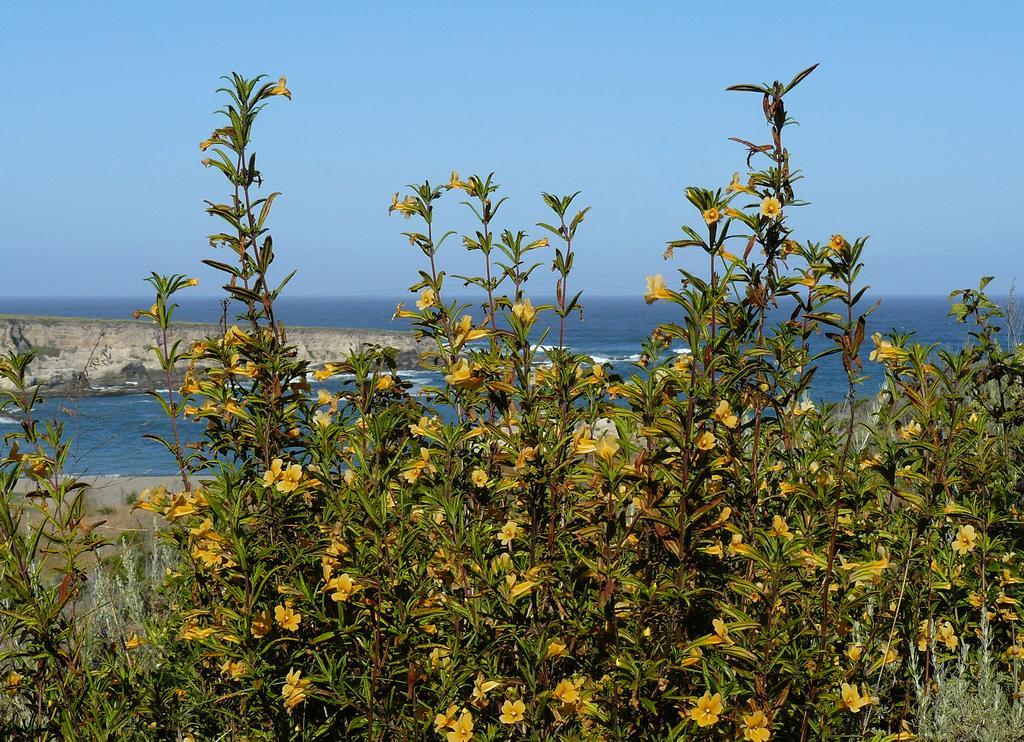Can you describe this image briefly? In this picture I can see there are few plants with yellow flowers and in the backdrop there is a ocean and the sky is clear. 